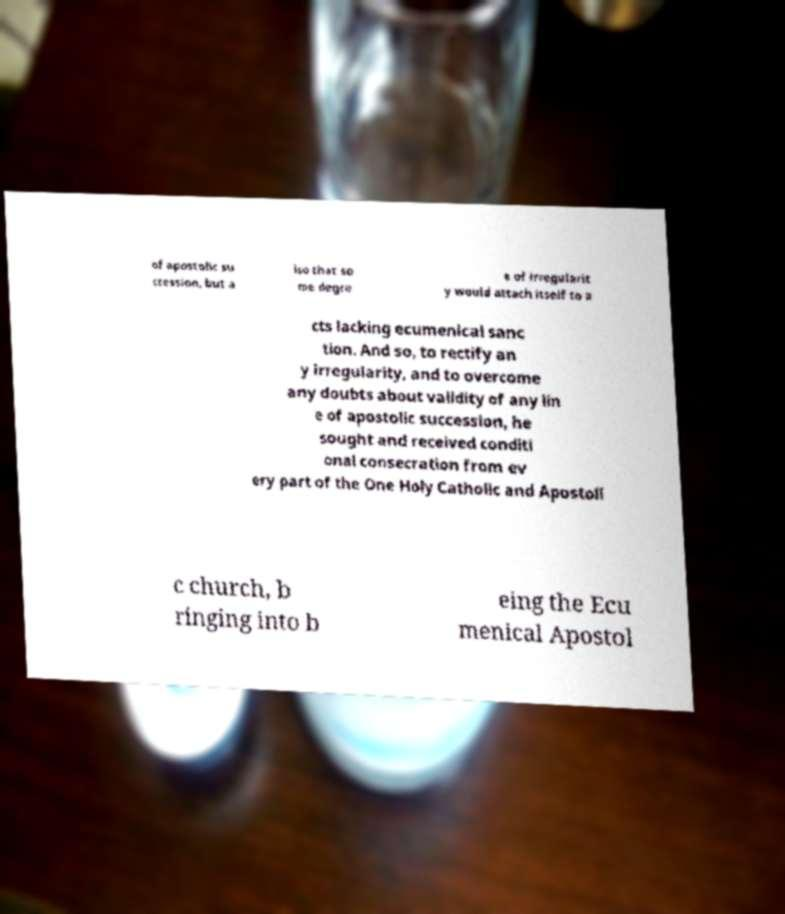What messages or text are displayed in this image? I need them in a readable, typed format. of apostolic su ccession, but a lso that so me degre e of irregularit y would attach itself to a cts lacking ecumenical sanc tion. And so, to rectify an y irregularity, and to overcome any doubts about validity of any lin e of apostolic succession, he sought and received conditi onal consecration from ev ery part of the One Holy Catholic and Apostoli c church, b ringing into b eing the Ecu menical Apostol 